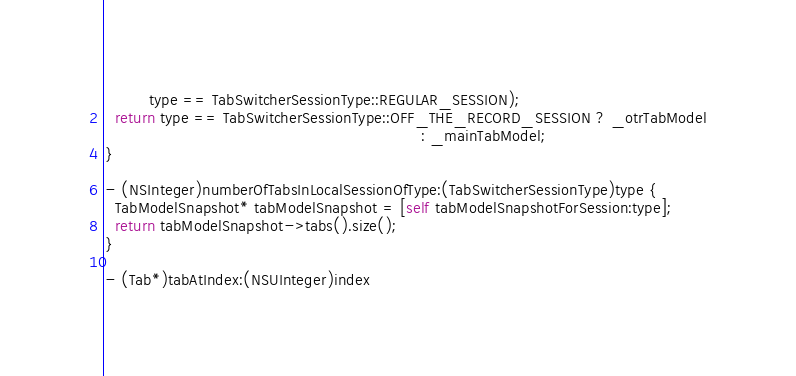Convert code to text. <code><loc_0><loc_0><loc_500><loc_500><_ObjectiveC_>         type == TabSwitcherSessionType::REGULAR_SESSION);
  return type == TabSwitcherSessionType::OFF_THE_RECORD_SESSION ? _otrTabModel
                                                                : _mainTabModel;
}

- (NSInteger)numberOfTabsInLocalSessionOfType:(TabSwitcherSessionType)type {
  TabModelSnapshot* tabModelSnapshot = [self tabModelSnapshotForSession:type];
  return tabModelSnapshot->tabs().size();
}

- (Tab*)tabAtIndex:(NSUInteger)index</code> 